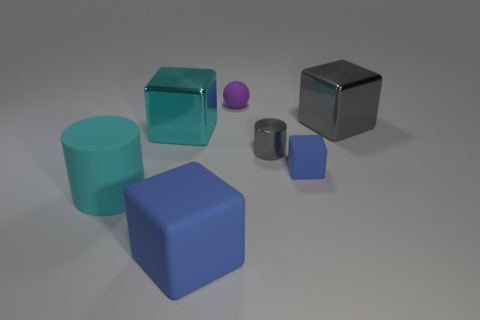The rubber thing that is the same color as the tiny matte cube is what size?
Keep it short and to the point. Large. Is there a big rubber object that has the same shape as the small blue rubber object?
Keep it short and to the point. Yes. There is a matte cube to the right of the small matte sphere; is its size the same as the gray shiny thing that is behind the small cylinder?
Your answer should be compact. No. Is the number of big objects greater than the number of big gray cubes?
Make the answer very short. Yes. How many large gray blocks have the same material as the tiny gray cylinder?
Keep it short and to the point. 1. Does the purple matte object have the same shape as the large cyan rubber object?
Give a very brief answer. No. How big is the blue object that is on the left side of the blue object to the right of the blue object that is in front of the large cyan cylinder?
Offer a terse response. Large. There is a blue rubber thing behind the big rubber block; are there any blue objects that are in front of it?
Offer a terse response. Yes. How many small blue things are on the left side of the small matte object that is behind the metallic thing right of the tiny matte block?
Offer a terse response. 0. What is the color of the big block that is both on the left side of the large gray shiny thing and behind the large blue matte cube?
Make the answer very short. Cyan. 